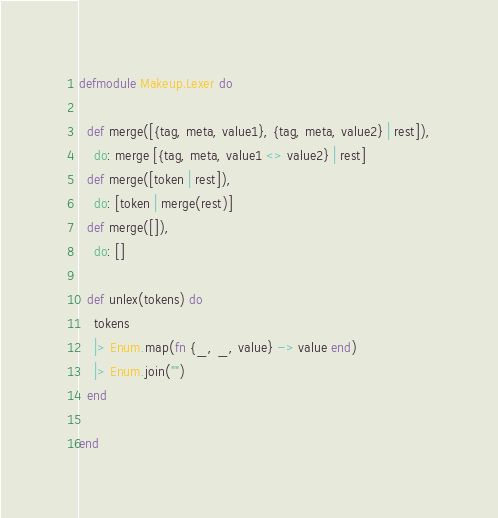Convert code to text. <code><loc_0><loc_0><loc_500><loc_500><_Elixir_>defmodule Makeup.Lexer do
  
  def merge([{tag, meta, value1}, {tag, meta, value2} | rest]),
    do: merge [{tag, meta, value1 <> value2} | rest]
  def merge([token | rest]),
    do: [token | merge(rest)]
  def merge([]),
    do: []

  def unlex(tokens) do
    tokens
    |> Enum.map(fn {_, _, value} -> value end)
    |> Enum.join("")
  end

end</code> 